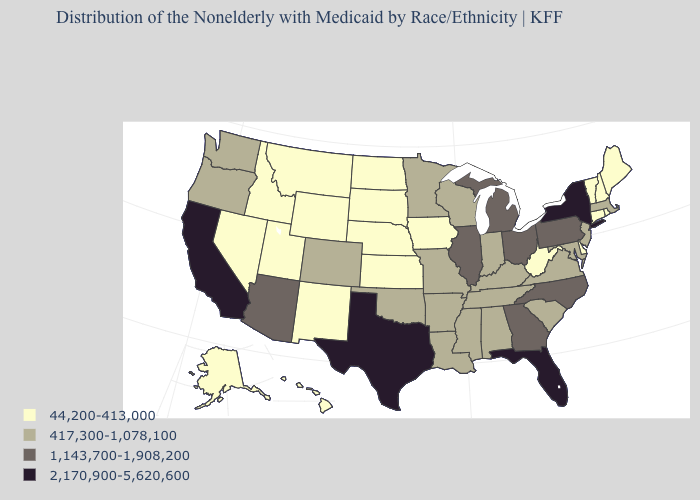What is the lowest value in states that border Rhode Island?
Short answer required. 44,200-413,000. What is the value of New Hampshire?
Write a very short answer. 44,200-413,000. What is the highest value in the USA?
Concise answer only. 2,170,900-5,620,600. Which states hav the highest value in the South?
Answer briefly. Florida, Texas. Name the states that have a value in the range 44,200-413,000?
Be succinct. Alaska, Connecticut, Delaware, Hawaii, Idaho, Iowa, Kansas, Maine, Montana, Nebraska, Nevada, New Hampshire, New Mexico, North Dakota, Rhode Island, South Dakota, Utah, Vermont, West Virginia, Wyoming. Name the states that have a value in the range 44,200-413,000?
Keep it brief. Alaska, Connecticut, Delaware, Hawaii, Idaho, Iowa, Kansas, Maine, Montana, Nebraska, Nevada, New Hampshire, New Mexico, North Dakota, Rhode Island, South Dakota, Utah, Vermont, West Virginia, Wyoming. Among the states that border Rhode Island , which have the lowest value?
Give a very brief answer. Connecticut. What is the highest value in states that border Rhode Island?
Concise answer only. 417,300-1,078,100. Among the states that border Tennessee , does Virginia have the lowest value?
Be succinct. Yes. Name the states that have a value in the range 1,143,700-1,908,200?
Concise answer only. Arizona, Georgia, Illinois, Michigan, North Carolina, Ohio, Pennsylvania. Does Florida have the highest value in the USA?
Keep it brief. Yes. Name the states that have a value in the range 417,300-1,078,100?
Concise answer only. Alabama, Arkansas, Colorado, Indiana, Kentucky, Louisiana, Maryland, Massachusetts, Minnesota, Mississippi, Missouri, New Jersey, Oklahoma, Oregon, South Carolina, Tennessee, Virginia, Washington, Wisconsin. Does the first symbol in the legend represent the smallest category?
Short answer required. Yes. What is the value of Alabama?
Keep it brief. 417,300-1,078,100. Which states have the highest value in the USA?
Write a very short answer. California, Florida, New York, Texas. 